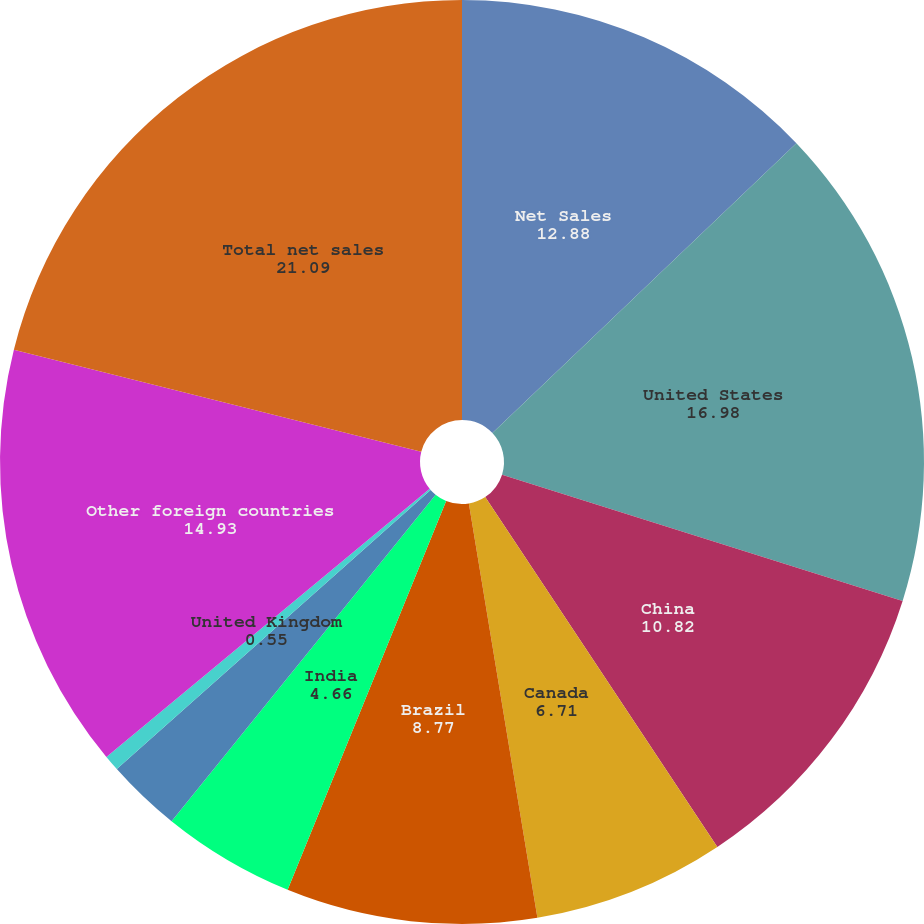Convert chart to OTSL. <chart><loc_0><loc_0><loc_500><loc_500><pie_chart><fcel>Net Sales<fcel>United States<fcel>China<fcel>Canada<fcel>Brazil<fcel>India<fcel>Mexico<fcel>United Kingdom<fcel>Other foreign countries<fcel>Total net sales<nl><fcel>12.88%<fcel>16.98%<fcel>10.82%<fcel>6.71%<fcel>8.77%<fcel>4.66%<fcel>2.61%<fcel>0.55%<fcel>14.93%<fcel>21.09%<nl></chart> 